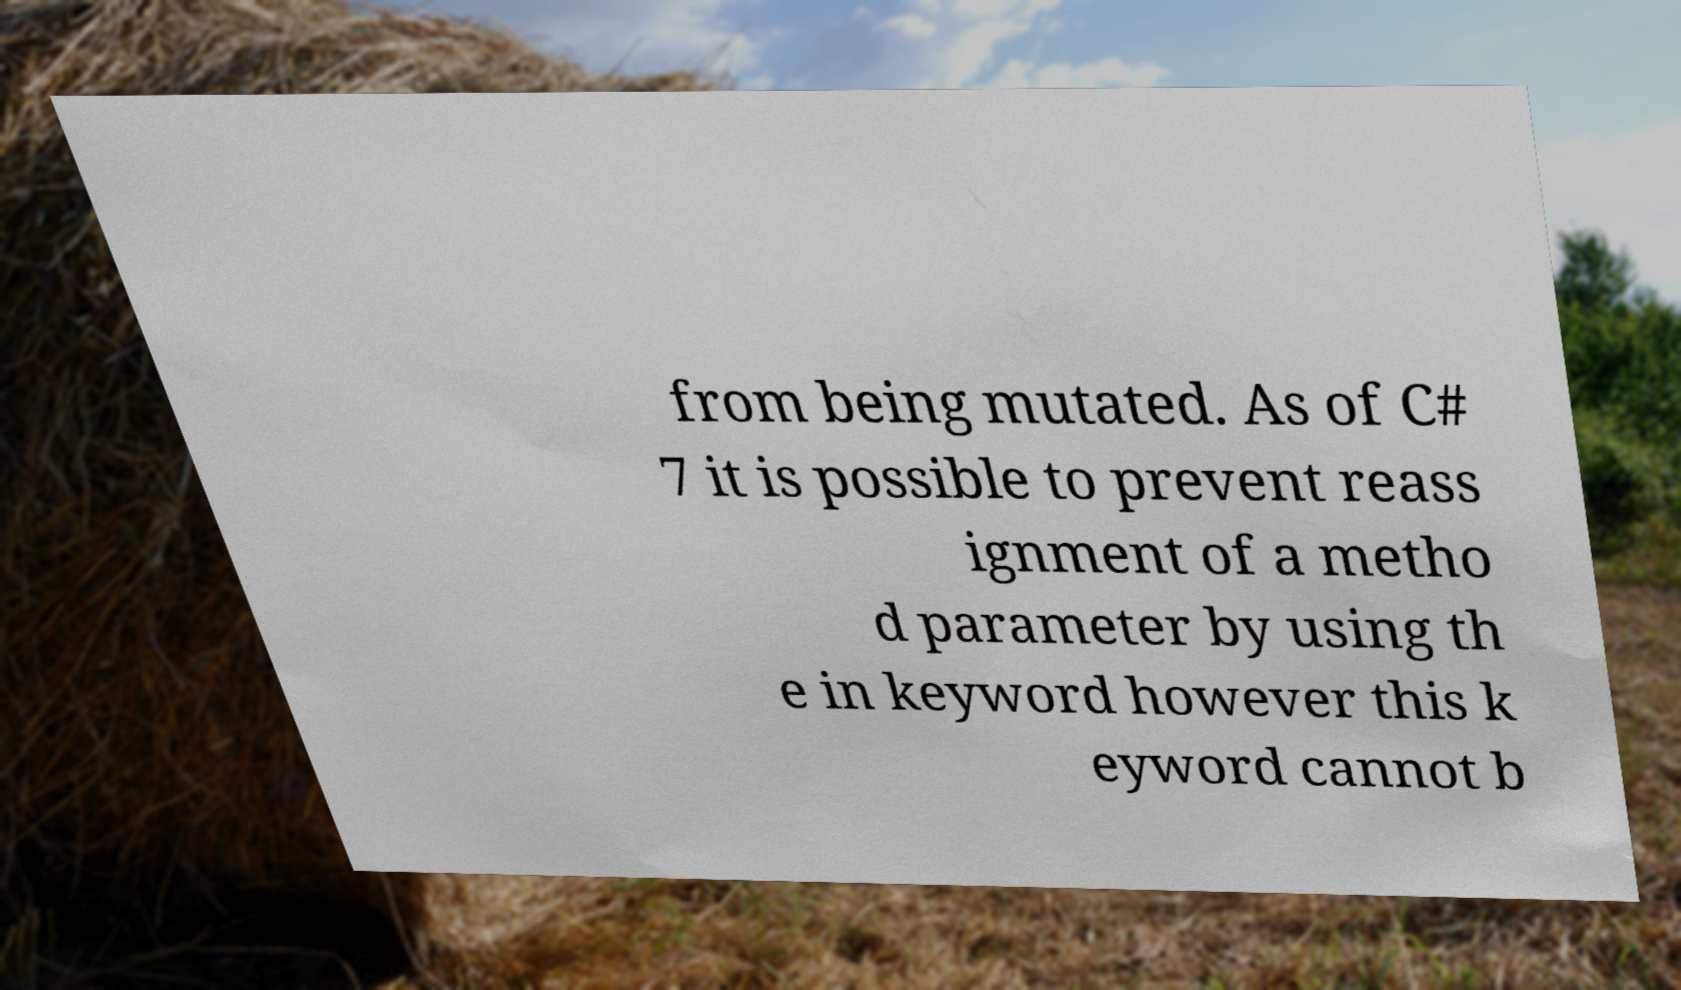I need the written content from this picture converted into text. Can you do that? from being mutated. As of C# 7 it is possible to prevent reass ignment of a metho d parameter by using th e in keyword however this k eyword cannot b 